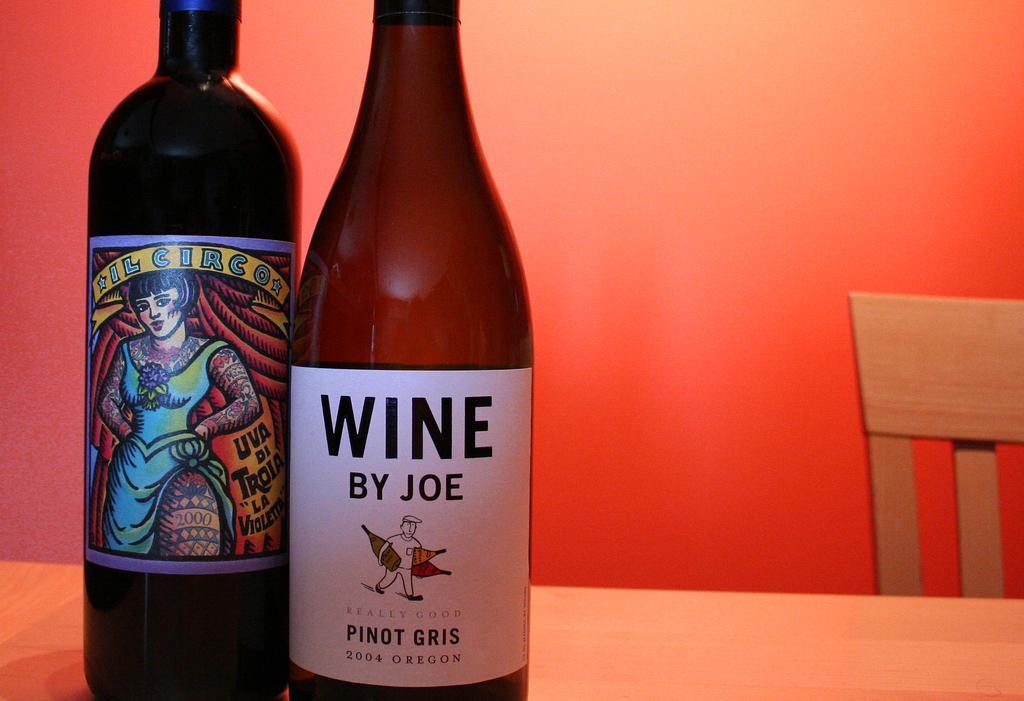<image>
Offer a succinct explanation of the picture presented. Bottle of Wine by Joe next to another beer bottle. 